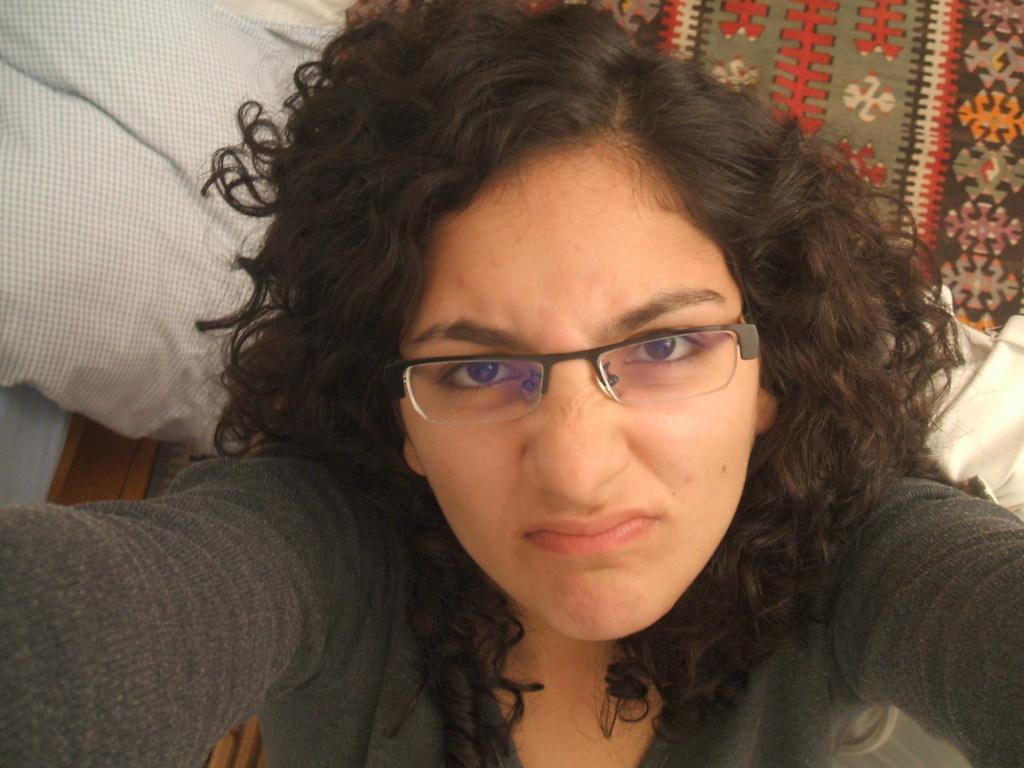Who is present in the image? There is a woman in the image. What is the woman wearing on her face? The woman is wearing spectacles. What color is the t-shirt the woman is wearing? The woman is wearing a black color t-shirt. What type of furniture is visible in the image? There is a pillow and a blanket in the image. What type of pail is the woman using to taste the hands in the image? There is no pail or hands present in the image, so this question cannot be answered. 